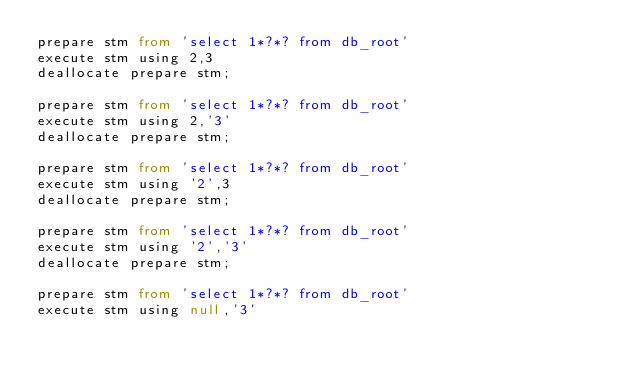<code> <loc_0><loc_0><loc_500><loc_500><_SQL_>prepare stm from 'select 1*?*? from db_root'
execute stm using 2,3
deallocate prepare stm;

prepare stm from 'select 1*?*? from db_root'
execute stm using 2,'3'
deallocate prepare stm;

prepare stm from 'select 1*?*? from db_root'
execute stm using '2',3
deallocate prepare stm;

prepare stm from 'select 1*?*? from db_root'
execute stm using '2','3'
deallocate prepare stm;

prepare stm from 'select 1*?*? from db_root'
execute stm using null,'3'</code> 